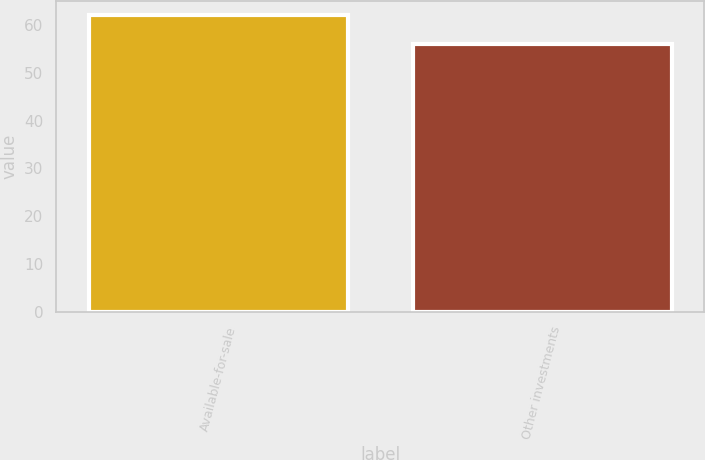Convert chart. <chart><loc_0><loc_0><loc_500><loc_500><bar_chart><fcel>Available-for-sale<fcel>Other investments<nl><fcel>62<fcel>56<nl></chart> 